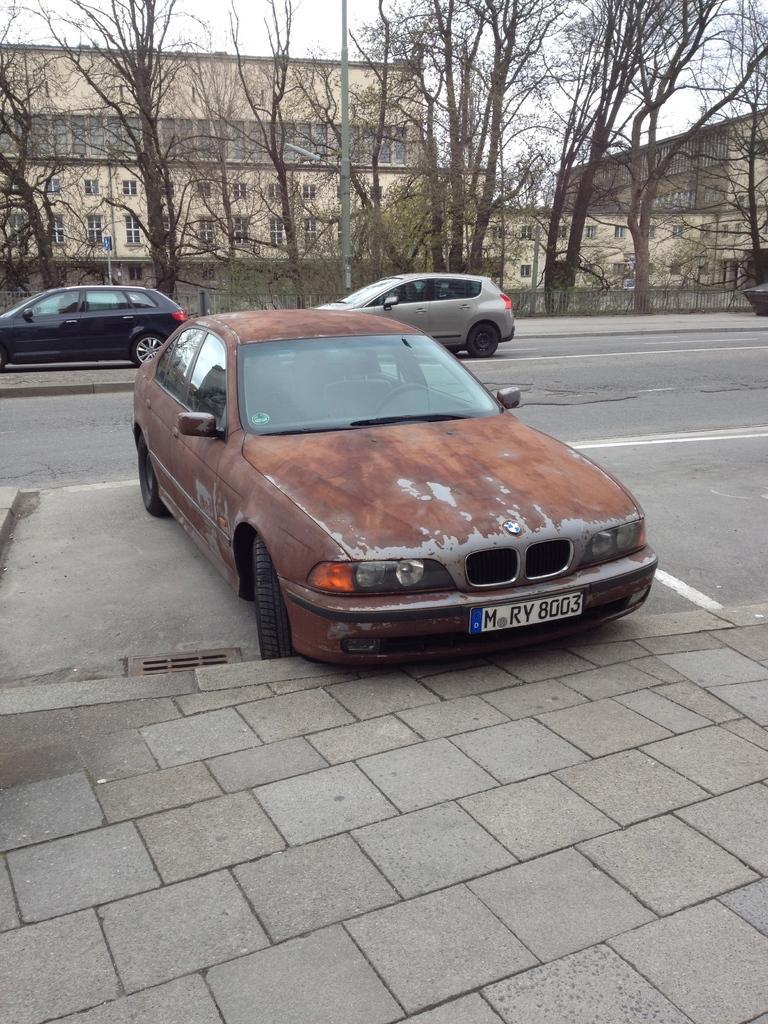Can you describe this image briefly? As we can see in the image there are cars, trees, buildings and sky. 